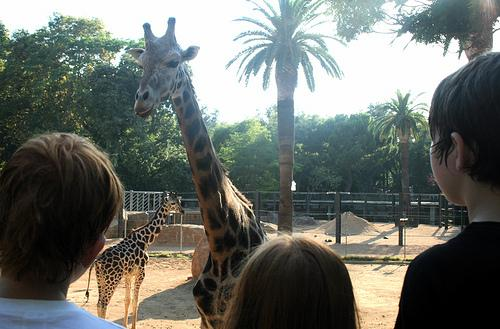How tall is the average newborn giraffe?

Choices:
A) 5 feet
B) 3 feet
C) 4 feet
D) 6 feet 6 feet 